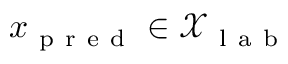<formula> <loc_0><loc_0><loc_500><loc_500>x _ { p r e d } \in \mathcal { X } _ { l a b }</formula> 